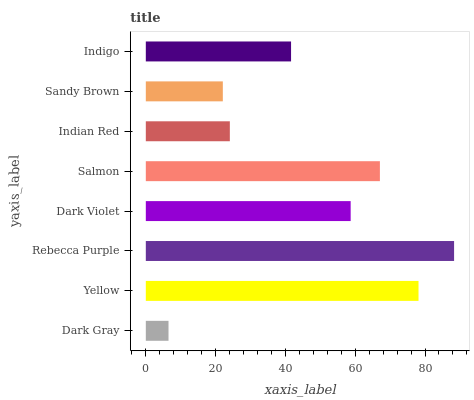Is Dark Gray the minimum?
Answer yes or no. Yes. Is Rebecca Purple the maximum?
Answer yes or no. Yes. Is Yellow the minimum?
Answer yes or no. No. Is Yellow the maximum?
Answer yes or no. No. Is Yellow greater than Dark Gray?
Answer yes or no. Yes. Is Dark Gray less than Yellow?
Answer yes or no. Yes. Is Dark Gray greater than Yellow?
Answer yes or no. No. Is Yellow less than Dark Gray?
Answer yes or no. No. Is Dark Violet the high median?
Answer yes or no. Yes. Is Indigo the low median?
Answer yes or no. Yes. Is Sandy Brown the high median?
Answer yes or no. No. Is Dark Gray the low median?
Answer yes or no. No. 